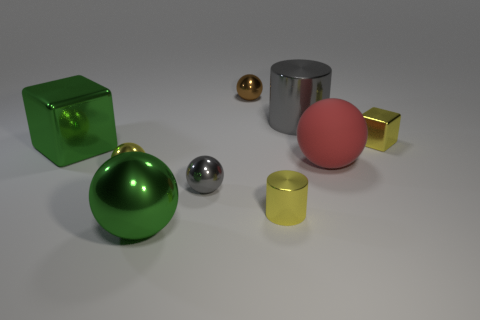Subtract all red balls. How many balls are left? 4 Subtract all tiny brown spheres. How many spheres are left? 4 Subtract all blue spheres. Subtract all red cubes. How many spheres are left? 5 Add 1 tiny brown objects. How many objects exist? 10 Subtract all cylinders. How many objects are left? 7 Subtract 0 cyan blocks. How many objects are left? 9 Subtract all big metal cylinders. Subtract all red spheres. How many objects are left? 7 Add 3 big green spheres. How many big green spheres are left? 4 Add 8 cyan blocks. How many cyan blocks exist? 8 